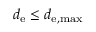<formula> <loc_0><loc_0><loc_500><loc_500>d _ { e } \leq d _ { e , \max }</formula> 